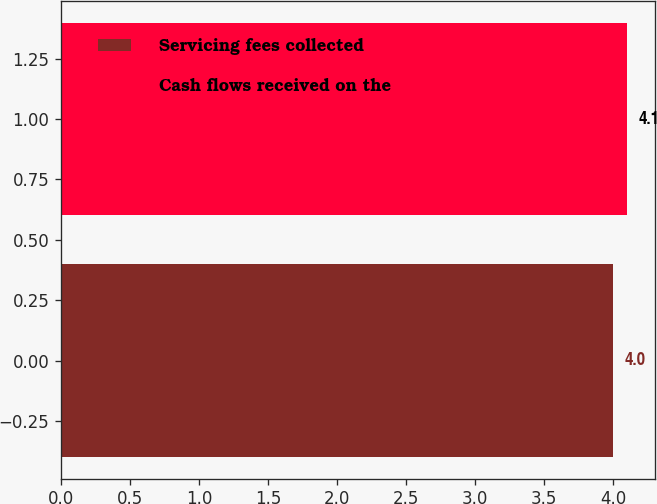Convert chart to OTSL. <chart><loc_0><loc_0><loc_500><loc_500><bar_chart><fcel>Servicing fees collected<fcel>Cash flows received on the<nl><fcel>4<fcel>4.1<nl></chart> 